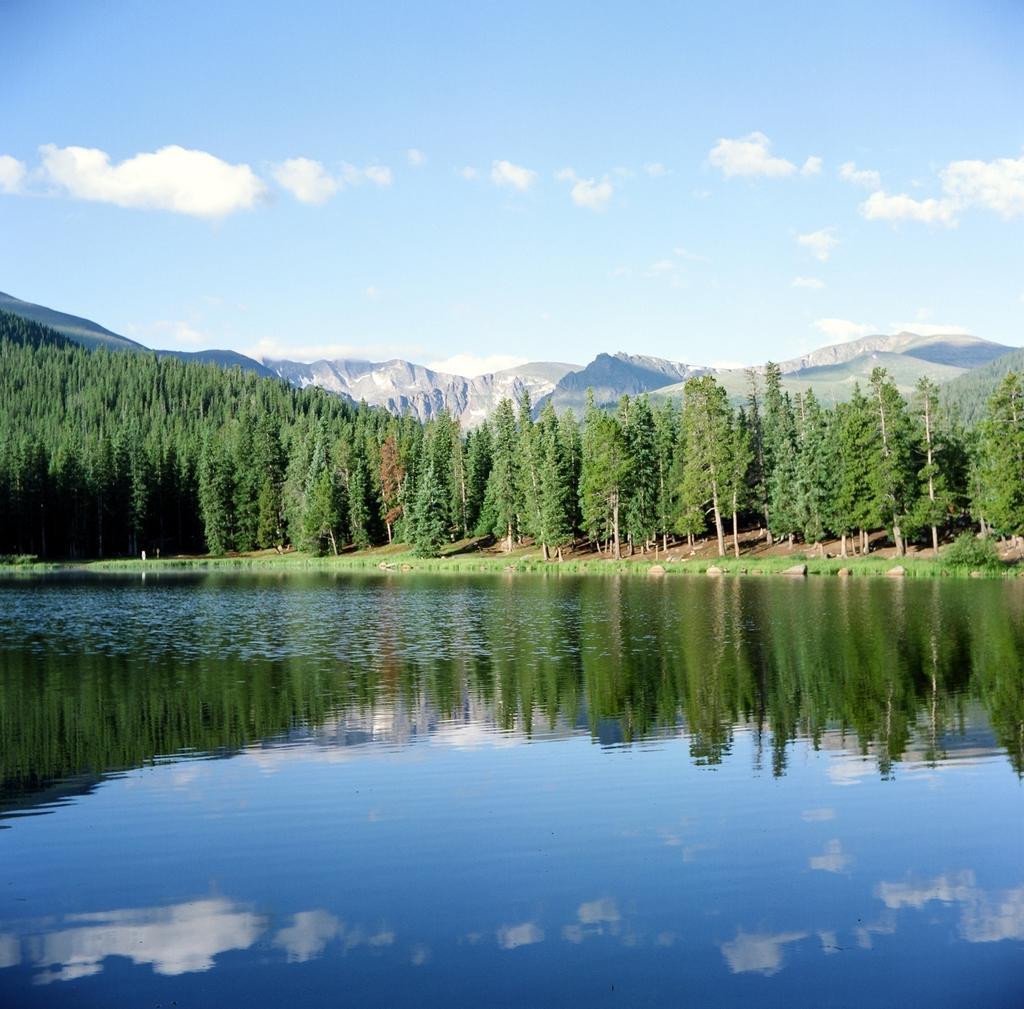Describe this image in one or two sentences. In this image I can see the water, the ground and few trees which are green and brown in color. In the background I can see few mountains and the sky. 